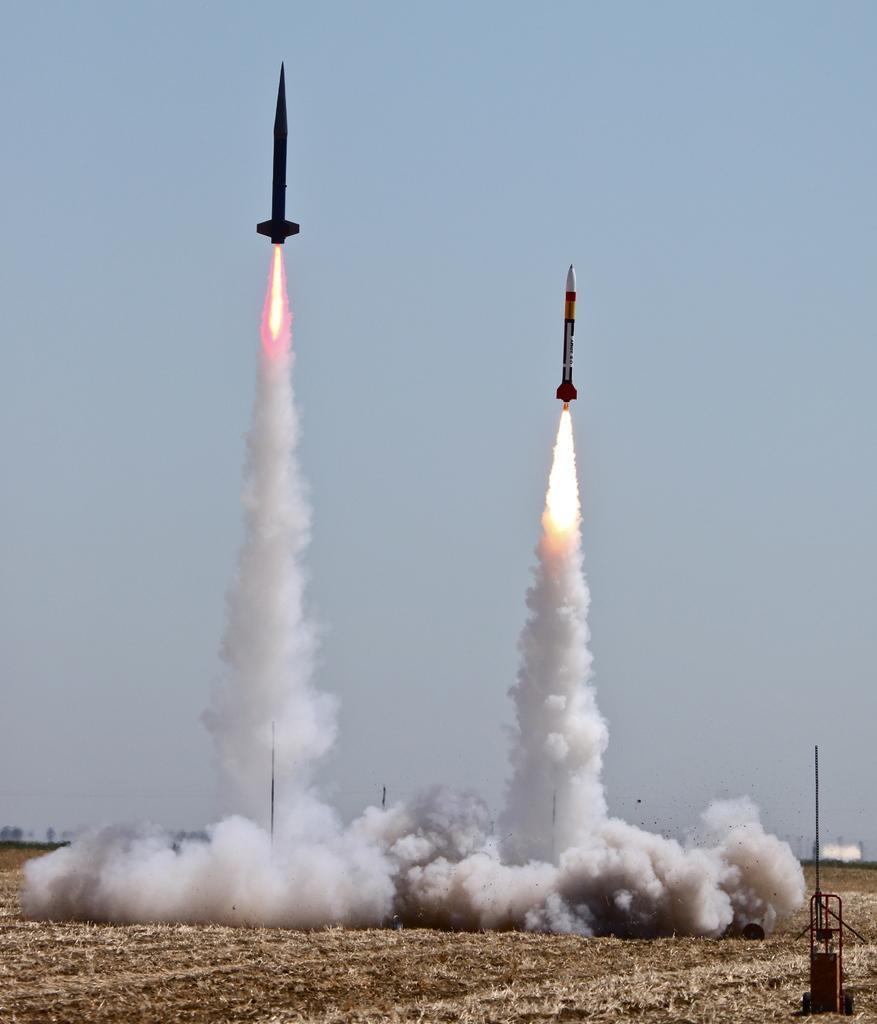Could you give a brief overview of what you see in this image? There are two rockets flying in the air and there is smoke under it. 